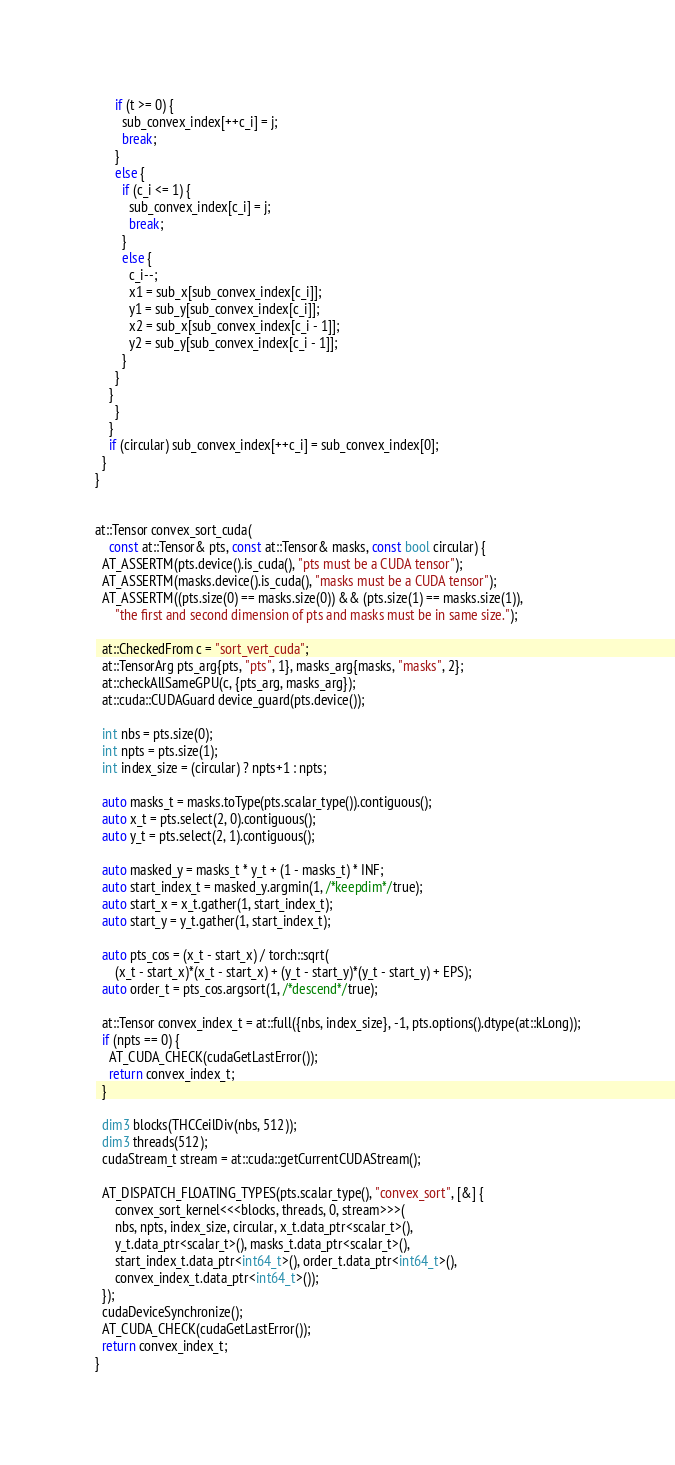Convert code to text. <code><loc_0><loc_0><loc_500><loc_500><_Cuda_>	  if (t >= 0) {
	    sub_convex_index[++c_i] = j;
	    break;
	  }
	  else {
	    if (c_i <= 1) {
	      sub_convex_index[c_i] = j;
	      break;
	    }
	    else {
	      c_i--;
	      x1 = sub_x[sub_convex_index[c_i]];
	      y1 = sub_y[sub_convex_index[c_i]];
	      x2 = sub_x[sub_convex_index[c_i - 1]];
	      y2 = sub_y[sub_convex_index[c_i - 1]];
	    }
	  }
	}
      }
    }
    if (circular) sub_convex_index[++c_i] = sub_convex_index[0];
  }
}


at::Tensor convex_sort_cuda(
    const at::Tensor& pts, const at::Tensor& masks, const bool circular) {
  AT_ASSERTM(pts.device().is_cuda(), "pts must be a CUDA tensor");
  AT_ASSERTM(masks.device().is_cuda(), "masks must be a CUDA tensor");
  AT_ASSERTM((pts.size(0) == masks.size(0)) && (pts.size(1) == masks.size(1)),
      "the first and second dimension of pts and masks must be in same size.");

  at::CheckedFrom c = "sort_vert_cuda";
  at::TensorArg pts_arg{pts, "pts", 1}, masks_arg{masks, "masks", 2};
  at::checkAllSameGPU(c, {pts_arg, masks_arg});
  at::cuda::CUDAGuard device_guard(pts.device());

  int nbs = pts.size(0);
  int npts = pts.size(1);
  int index_size = (circular) ? npts+1 : npts;

  auto masks_t = masks.toType(pts.scalar_type()).contiguous();
  auto x_t = pts.select(2, 0).contiguous();
  auto y_t = pts.select(2, 1).contiguous();

  auto masked_y = masks_t * y_t + (1 - masks_t) * INF;
  auto start_index_t = masked_y.argmin(1, /*keepdim*/true);
  auto start_x = x_t.gather(1, start_index_t);
  auto start_y = y_t.gather(1, start_index_t);

  auto pts_cos = (x_t - start_x) / torch::sqrt(
      (x_t - start_x)*(x_t - start_x) + (y_t - start_y)*(y_t - start_y) + EPS);
  auto order_t = pts_cos.argsort(1, /*descend*/true);

  at::Tensor convex_index_t = at::full({nbs, index_size}, -1, pts.options().dtype(at::kLong));
  if (npts == 0) {
    AT_CUDA_CHECK(cudaGetLastError());
    return convex_index_t;
  }

  dim3 blocks(THCCeilDiv(nbs, 512));
  dim3 threads(512);
  cudaStream_t stream = at::cuda::getCurrentCUDAStream();

  AT_DISPATCH_FLOATING_TYPES(pts.scalar_type(), "convex_sort", [&] {
      convex_sort_kernel<<<blocks, threads, 0, stream>>>(
	  nbs, npts, index_size, circular, x_t.data_ptr<scalar_t>(),
	  y_t.data_ptr<scalar_t>(), masks_t.data_ptr<scalar_t>(),
	  start_index_t.data_ptr<int64_t>(), order_t.data_ptr<int64_t>(),
	  convex_index_t.data_ptr<int64_t>());
  });
  cudaDeviceSynchronize();
  AT_CUDA_CHECK(cudaGetLastError());
  return convex_index_t;
}
</code> 